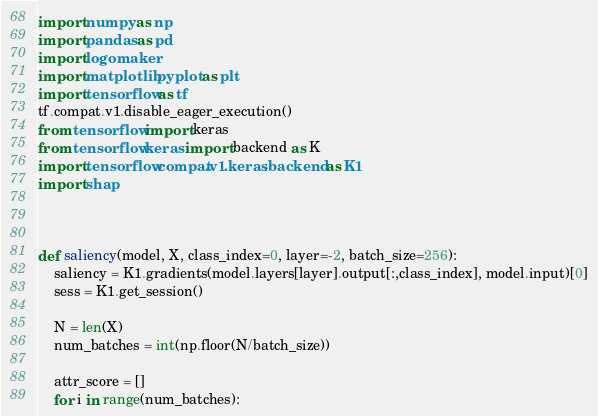Convert code to text. <code><loc_0><loc_0><loc_500><loc_500><_Python_>import numpy as np
import pandas as pd
import logomaker
import matplotlib.pyplot as plt
import tensorflow as tf
tf.compat.v1.disable_eager_execution()
from tensorflow import keras
from tensorflow.keras import backend as K
import tensorflow.compat.v1.keras.backend as K1
import shap



def saliency(model, X, class_index=0, layer=-2, batch_size=256):
    saliency = K1.gradients(model.layers[layer].output[:,class_index], model.input)[0]
    sess = K1.get_session()

    N = len(X)
    num_batches = int(np.floor(N/batch_size))

    attr_score = []
    for i in range(num_batches):</code> 